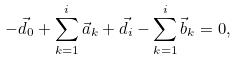Convert formula to latex. <formula><loc_0><loc_0><loc_500><loc_500>- \vec { d } _ { 0 } + \sum _ { k = 1 } ^ { i } \vec { a } _ { k } + \vec { d } _ { i } - \sum _ { k = 1 } ^ { i } \vec { b } _ { k } = 0 ,</formula> 